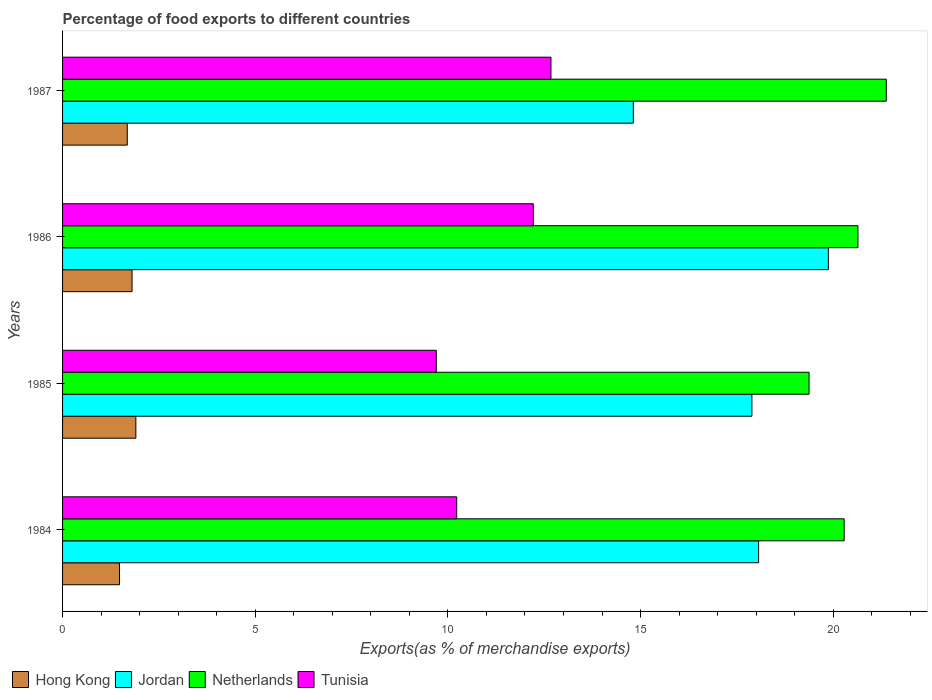Are the number of bars per tick equal to the number of legend labels?
Offer a very short reply. Yes. Are the number of bars on each tick of the Y-axis equal?
Offer a very short reply. Yes. What is the label of the 4th group of bars from the top?
Ensure brevity in your answer.  1984. In how many cases, is the number of bars for a given year not equal to the number of legend labels?
Keep it short and to the point. 0. What is the percentage of exports to different countries in Tunisia in 1985?
Your answer should be very brief. 9.7. Across all years, what is the maximum percentage of exports to different countries in Tunisia?
Make the answer very short. 12.67. Across all years, what is the minimum percentage of exports to different countries in Tunisia?
Keep it short and to the point. 9.7. What is the total percentage of exports to different countries in Netherlands in the graph?
Provide a succinct answer. 81.67. What is the difference between the percentage of exports to different countries in Tunisia in 1985 and that in 1986?
Offer a very short reply. -2.52. What is the difference between the percentage of exports to different countries in Netherlands in 1987 and the percentage of exports to different countries in Jordan in 1985?
Give a very brief answer. 3.49. What is the average percentage of exports to different countries in Netherlands per year?
Provide a short and direct response. 20.42. In the year 1984, what is the difference between the percentage of exports to different countries in Tunisia and percentage of exports to different countries in Jordan?
Your answer should be very brief. -7.83. What is the ratio of the percentage of exports to different countries in Netherlands in 1985 to that in 1987?
Offer a terse response. 0.91. Is the difference between the percentage of exports to different countries in Tunisia in 1986 and 1987 greater than the difference between the percentage of exports to different countries in Jordan in 1986 and 1987?
Your answer should be compact. No. What is the difference between the highest and the second highest percentage of exports to different countries in Jordan?
Give a very brief answer. 1.81. What is the difference between the highest and the lowest percentage of exports to different countries in Netherlands?
Provide a succinct answer. 2. In how many years, is the percentage of exports to different countries in Jordan greater than the average percentage of exports to different countries in Jordan taken over all years?
Ensure brevity in your answer.  3. Is the sum of the percentage of exports to different countries in Jordan in 1984 and 1985 greater than the maximum percentage of exports to different countries in Hong Kong across all years?
Give a very brief answer. Yes. What does the 4th bar from the top in 1986 represents?
Provide a succinct answer. Hong Kong. What does the 4th bar from the bottom in 1986 represents?
Your answer should be compact. Tunisia. How many bars are there?
Give a very brief answer. 16. Are all the bars in the graph horizontal?
Your response must be concise. Yes. How many years are there in the graph?
Your answer should be compact. 4. What is the difference between two consecutive major ticks on the X-axis?
Ensure brevity in your answer.  5. Does the graph contain any zero values?
Your response must be concise. No. Does the graph contain grids?
Offer a very short reply. No. What is the title of the graph?
Ensure brevity in your answer.  Percentage of food exports to different countries. What is the label or title of the X-axis?
Ensure brevity in your answer.  Exports(as % of merchandise exports). What is the label or title of the Y-axis?
Your answer should be compact. Years. What is the Exports(as % of merchandise exports) in Hong Kong in 1984?
Your answer should be compact. 1.48. What is the Exports(as % of merchandise exports) in Jordan in 1984?
Offer a terse response. 18.06. What is the Exports(as % of merchandise exports) in Netherlands in 1984?
Your response must be concise. 20.28. What is the Exports(as % of merchandise exports) of Tunisia in 1984?
Provide a short and direct response. 10.23. What is the Exports(as % of merchandise exports) of Hong Kong in 1985?
Ensure brevity in your answer.  1.9. What is the Exports(as % of merchandise exports) in Jordan in 1985?
Offer a very short reply. 17.89. What is the Exports(as % of merchandise exports) of Netherlands in 1985?
Provide a succinct answer. 19.37. What is the Exports(as % of merchandise exports) in Tunisia in 1985?
Your answer should be very brief. 9.7. What is the Exports(as % of merchandise exports) of Hong Kong in 1986?
Make the answer very short. 1.8. What is the Exports(as % of merchandise exports) in Jordan in 1986?
Your answer should be compact. 19.87. What is the Exports(as % of merchandise exports) in Netherlands in 1986?
Your response must be concise. 20.64. What is the Exports(as % of merchandise exports) in Tunisia in 1986?
Give a very brief answer. 12.22. What is the Exports(as % of merchandise exports) of Hong Kong in 1987?
Offer a very short reply. 1.68. What is the Exports(as % of merchandise exports) in Jordan in 1987?
Ensure brevity in your answer.  14.81. What is the Exports(as % of merchandise exports) in Netherlands in 1987?
Offer a terse response. 21.38. What is the Exports(as % of merchandise exports) in Tunisia in 1987?
Offer a terse response. 12.67. Across all years, what is the maximum Exports(as % of merchandise exports) of Hong Kong?
Offer a very short reply. 1.9. Across all years, what is the maximum Exports(as % of merchandise exports) of Jordan?
Your answer should be compact. 19.87. Across all years, what is the maximum Exports(as % of merchandise exports) of Netherlands?
Offer a very short reply. 21.38. Across all years, what is the maximum Exports(as % of merchandise exports) of Tunisia?
Offer a terse response. 12.67. Across all years, what is the minimum Exports(as % of merchandise exports) in Hong Kong?
Offer a terse response. 1.48. Across all years, what is the minimum Exports(as % of merchandise exports) in Jordan?
Your response must be concise. 14.81. Across all years, what is the minimum Exports(as % of merchandise exports) in Netherlands?
Provide a succinct answer. 19.37. Across all years, what is the minimum Exports(as % of merchandise exports) of Tunisia?
Offer a terse response. 9.7. What is the total Exports(as % of merchandise exports) in Hong Kong in the graph?
Offer a very short reply. 6.86. What is the total Exports(as % of merchandise exports) of Jordan in the graph?
Provide a short and direct response. 70.64. What is the total Exports(as % of merchandise exports) in Netherlands in the graph?
Offer a terse response. 81.67. What is the total Exports(as % of merchandise exports) in Tunisia in the graph?
Keep it short and to the point. 44.82. What is the difference between the Exports(as % of merchandise exports) in Hong Kong in 1984 and that in 1985?
Provide a short and direct response. -0.42. What is the difference between the Exports(as % of merchandise exports) in Jordan in 1984 and that in 1985?
Your response must be concise. 0.17. What is the difference between the Exports(as % of merchandise exports) in Netherlands in 1984 and that in 1985?
Make the answer very short. 0.91. What is the difference between the Exports(as % of merchandise exports) of Tunisia in 1984 and that in 1985?
Give a very brief answer. 0.53. What is the difference between the Exports(as % of merchandise exports) in Hong Kong in 1984 and that in 1986?
Your answer should be compact. -0.33. What is the difference between the Exports(as % of merchandise exports) of Jordan in 1984 and that in 1986?
Ensure brevity in your answer.  -1.81. What is the difference between the Exports(as % of merchandise exports) in Netherlands in 1984 and that in 1986?
Offer a very short reply. -0.36. What is the difference between the Exports(as % of merchandise exports) in Tunisia in 1984 and that in 1986?
Make the answer very short. -1.99. What is the difference between the Exports(as % of merchandise exports) in Hong Kong in 1984 and that in 1987?
Provide a short and direct response. -0.2. What is the difference between the Exports(as % of merchandise exports) of Jordan in 1984 and that in 1987?
Ensure brevity in your answer.  3.25. What is the difference between the Exports(as % of merchandise exports) in Netherlands in 1984 and that in 1987?
Give a very brief answer. -1.09. What is the difference between the Exports(as % of merchandise exports) in Tunisia in 1984 and that in 1987?
Offer a very short reply. -2.45. What is the difference between the Exports(as % of merchandise exports) of Hong Kong in 1985 and that in 1986?
Your answer should be very brief. 0.1. What is the difference between the Exports(as % of merchandise exports) of Jordan in 1985 and that in 1986?
Your answer should be very brief. -1.98. What is the difference between the Exports(as % of merchandise exports) of Netherlands in 1985 and that in 1986?
Give a very brief answer. -1.27. What is the difference between the Exports(as % of merchandise exports) in Tunisia in 1985 and that in 1986?
Keep it short and to the point. -2.52. What is the difference between the Exports(as % of merchandise exports) of Hong Kong in 1985 and that in 1987?
Provide a short and direct response. 0.22. What is the difference between the Exports(as % of merchandise exports) of Jordan in 1985 and that in 1987?
Give a very brief answer. 3.08. What is the difference between the Exports(as % of merchandise exports) of Netherlands in 1985 and that in 1987?
Provide a short and direct response. -2. What is the difference between the Exports(as % of merchandise exports) of Tunisia in 1985 and that in 1987?
Give a very brief answer. -2.98. What is the difference between the Exports(as % of merchandise exports) of Hong Kong in 1986 and that in 1987?
Provide a succinct answer. 0.12. What is the difference between the Exports(as % of merchandise exports) in Jordan in 1986 and that in 1987?
Your answer should be very brief. 5.06. What is the difference between the Exports(as % of merchandise exports) in Netherlands in 1986 and that in 1987?
Your answer should be compact. -0.74. What is the difference between the Exports(as % of merchandise exports) in Tunisia in 1986 and that in 1987?
Keep it short and to the point. -0.46. What is the difference between the Exports(as % of merchandise exports) of Hong Kong in 1984 and the Exports(as % of merchandise exports) of Jordan in 1985?
Ensure brevity in your answer.  -16.41. What is the difference between the Exports(as % of merchandise exports) in Hong Kong in 1984 and the Exports(as % of merchandise exports) in Netherlands in 1985?
Ensure brevity in your answer.  -17.89. What is the difference between the Exports(as % of merchandise exports) of Hong Kong in 1984 and the Exports(as % of merchandise exports) of Tunisia in 1985?
Your answer should be very brief. -8.22. What is the difference between the Exports(as % of merchandise exports) in Jordan in 1984 and the Exports(as % of merchandise exports) in Netherlands in 1985?
Make the answer very short. -1.31. What is the difference between the Exports(as % of merchandise exports) of Jordan in 1984 and the Exports(as % of merchandise exports) of Tunisia in 1985?
Make the answer very short. 8.36. What is the difference between the Exports(as % of merchandise exports) in Netherlands in 1984 and the Exports(as % of merchandise exports) in Tunisia in 1985?
Your answer should be compact. 10.58. What is the difference between the Exports(as % of merchandise exports) in Hong Kong in 1984 and the Exports(as % of merchandise exports) in Jordan in 1986?
Provide a succinct answer. -18.4. What is the difference between the Exports(as % of merchandise exports) in Hong Kong in 1984 and the Exports(as % of merchandise exports) in Netherlands in 1986?
Your answer should be compact. -19.16. What is the difference between the Exports(as % of merchandise exports) in Hong Kong in 1984 and the Exports(as % of merchandise exports) in Tunisia in 1986?
Offer a very short reply. -10.74. What is the difference between the Exports(as % of merchandise exports) in Jordan in 1984 and the Exports(as % of merchandise exports) in Netherlands in 1986?
Offer a very short reply. -2.58. What is the difference between the Exports(as % of merchandise exports) of Jordan in 1984 and the Exports(as % of merchandise exports) of Tunisia in 1986?
Give a very brief answer. 5.85. What is the difference between the Exports(as % of merchandise exports) of Netherlands in 1984 and the Exports(as % of merchandise exports) of Tunisia in 1986?
Your answer should be compact. 8.07. What is the difference between the Exports(as % of merchandise exports) of Hong Kong in 1984 and the Exports(as % of merchandise exports) of Jordan in 1987?
Offer a terse response. -13.33. What is the difference between the Exports(as % of merchandise exports) in Hong Kong in 1984 and the Exports(as % of merchandise exports) in Netherlands in 1987?
Offer a terse response. -19.9. What is the difference between the Exports(as % of merchandise exports) in Hong Kong in 1984 and the Exports(as % of merchandise exports) in Tunisia in 1987?
Provide a short and direct response. -11.2. What is the difference between the Exports(as % of merchandise exports) in Jordan in 1984 and the Exports(as % of merchandise exports) in Netherlands in 1987?
Give a very brief answer. -3.31. What is the difference between the Exports(as % of merchandise exports) in Jordan in 1984 and the Exports(as % of merchandise exports) in Tunisia in 1987?
Make the answer very short. 5.39. What is the difference between the Exports(as % of merchandise exports) of Netherlands in 1984 and the Exports(as % of merchandise exports) of Tunisia in 1987?
Your answer should be very brief. 7.61. What is the difference between the Exports(as % of merchandise exports) of Hong Kong in 1985 and the Exports(as % of merchandise exports) of Jordan in 1986?
Keep it short and to the point. -17.97. What is the difference between the Exports(as % of merchandise exports) of Hong Kong in 1985 and the Exports(as % of merchandise exports) of Netherlands in 1986?
Make the answer very short. -18.74. What is the difference between the Exports(as % of merchandise exports) of Hong Kong in 1985 and the Exports(as % of merchandise exports) of Tunisia in 1986?
Your answer should be compact. -10.31. What is the difference between the Exports(as % of merchandise exports) in Jordan in 1985 and the Exports(as % of merchandise exports) in Netherlands in 1986?
Your answer should be very brief. -2.75. What is the difference between the Exports(as % of merchandise exports) in Jordan in 1985 and the Exports(as % of merchandise exports) in Tunisia in 1986?
Offer a terse response. 5.67. What is the difference between the Exports(as % of merchandise exports) of Netherlands in 1985 and the Exports(as % of merchandise exports) of Tunisia in 1986?
Make the answer very short. 7.16. What is the difference between the Exports(as % of merchandise exports) in Hong Kong in 1985 and the Exports(as % of merchandise exports) in Jordan in 1987?
Offer a terse response. -12.91. What is the difference between the Exports(as % of merchandise exports) of Hong Kong in 1985 and the Exports(as % of merchandise exports) of Netherlands in 1987?
Provide a succinct answer. -19.47. What is the difference between the Exports(as % of merchandise exports) of Hong Kong in 1985 and the Exports(as % of merchandise exports) of Tunisia in 1987?
Offer a terse response. -10.77. What is the difference between the Exports(as % of merchandise exports) of Jordan in 1985 and the Exports(as % of merchandise exports) of Netherlands in 1987?
Your answer should be compact. -3.49. What is the difference between the Exports(as % of merchandise exports) in Jordan in 1985 and the Exports(as % of merchandise exports) in Tunisia in 1987?
Offer a very short reply. 5.21. What is the difference between the Exports(as % of merchandise exports) of Netherlands in 1985 and the Exports(as % of merchandise exports) of Tunisia in 1987?
Offer a very short reply. 6.7. What is the difference between the Exports(as % of merchandise exports) of Hong Kong in 1986 and the Exports(as % of merchandise exports) of Jordan in 1987?
Make the answer very short. -13.01. What is the difference between the Exports(as % of merchandise exports) of Hong Kong in 1986 and the Exports(as % of merchandise exports) of Netherlands in 1987?
Give a very brief answer. -19.57. What is the difference between the Exports(as % of merchandise exports) of Hong Kong in 1986 and the Exports(as % of merchandise exports) of Tunisia in 1987?
Give a very brief answer. -10.87. What is the difference between the Exports(as % of merchandise exports) in Jordan in 1986 and the Exports(as % of merchandise exports) in Netherlands in 1987?
Provide a short and direct response. -1.5. What is the difference between the Exports(as % of merchandise exports) in Jordan in 1986 and the Exports(as % of merchandise exports) in Tunisia in 1987?
Offer a terse response. 7.2. What is the difference between the Exports(as % of merchandise exports) in Netherlands in 1986 and the Exports(as % of merchandise exports) in Tunisia in 1987?
Offer a terse response. 7.97. What is the average Exports(as % of merchandise exports) in Hong Kong per year?
Ensure brevity in your answer.  1.72. What is the average Exports(as % of merchandise exports) of Jordan per year?
Your answer should be very brief. 17.66. What is the average Exports(as % of merchandise exports) in Netherlands per year?
Give a very brief answer. 20.42. What is the average Exports(as % of merchandise exports) in Tunisia per year?
Make the answer very short. 11.2. In the year 1984, what is the difference between the Exports(as % of merchandise exports) in Hong Kong and Exports(as % of merchandise exports) in Jordan?
Provide a succinct answer. -16.58. In the year 1984, what is the difference between the Exports(as % of merchandise exports) of Hong Kong and Exports(as % of merchandise exports) of Netherlands?
Your answer should be compact. -18.8. In the year 1984, what is the difference between the Exports(as % of merchandise exports) in Hong Kong and Exports(as % of merchandise exports) in Tunisia?
Keep it short and to the point. -8.75. In the year 1984, what is the difference between the Exports(as % of merchandise exports) of Jordan and Exports(as % of merchandise exports) of Netherlands?
Provide a short and direct response. -2.22. In the year 1984, what is the difference between the Exports(as % of merchandise exports) of Jordan and Exports(as % of merchandise exports) of Tunisia?
Your answer should be compact. 7.83. In the year 1984, what is the difference between the Exports(as % of merchandise exports) in Netherlands and Exports(as % of merchandise exports) in Tunisia?
Keep it short and to the point. 10.05. In the year 1985, what is the difference between the Exports(as % of merchandise exports) of Hong Kong and Exports(as % of merchandise exports) of Jordan?
Offer a very short reply. -15.99. In the year 1985, what is the difference between the Exports(as % of merchandise exports) in Hong Kong and Exports(as % of merchandise exports) in Netherlands?
Keep it short and to the point. -17.47. In the year 1985, what is the difference between the Exports(as % of merchandise exports) of Hong Kong and Exports(as % of merchandise exports) of Tunisia?
Provide a succinct answer. -7.8. In the year 1985, what is the difference between the Exports(as % of merchandise exports) in Jordan and Exports(as % of merchandise exports) in Netherlands?
Provide a short and direct response. -1.48. In the year 1985, what is the difference between the Exports(as % of merchandise exports) of Jordan and Exports(as % of merchandise exports) of Tunisia?
Your answer should be very brief. 8.19. In the year 1985, what is the difference between the Exports(as % of merchandise exports) of Netherlands and Exports(as % of merchandise exports) of Tunisia?
Offer a terse response. 9.67. In the year 1986, what is the difference between the Exports(as % of merchandise exports) in Hong Kong and Exports(as % of merchandise exports) in Jordan?
Offer a very short reply. -18.07. In the year 1986, what is the difference between the Exports(as % of merchandise exports) in Hong Kong and Exports(as % of merchandise exports) in Netherlands?
Provide a succinct answer. -18.84. In the year 1986, what is the difference between the Exports(as % of merchandise exports) of Hong Kong and Exports(as % of merchandise exports) of Tunisia?
Ensure brevity in your answer.  -10.41. In the year 1986, what is the difference between the Exports(as % of merchandise exports) in Jordan and Exports(as % of merchandise exports) in Netherlands?
Provide a succinct answer. -0.77. In the year 1986, what is the difference between the Exports(as % of merchandise exports) of Jordan and Exports(as % of merchandise exports) of Tunisia?
Your answer should be compact. 7.66. In the year 1986, what is the difference between the Exports(as % of merchandise exports) of Netherlands and Exports(as % of merchandise exports) of Tunisia?
Keep it short and to the point. 8.42. In the year 1987, what is the difference between the Exports(as % of merchandise exports) of Hong Kong and Exports(as % of merchandise exports) of Jordan?
Ensure brevity in your answer.  -13.13. In the year 1987, what is the difference between the Exports(as % of merchandise exports) in Hong Kong and Exports(as % of merchandise exports) in Netherlands?
Provide a succinct answer. -19.7. In the year 1987, what is the difference between the Exports(as % of merchandise exports) in Hong Kong and Exports(as % of merchandise exports) in Tunisia?
Your answer should be compact. -10.99. In the year 1987, what is the difference between the Exports(as % of merchandise exports) of Jordan and Exports(as % of merchandise exports) of Netherlands?
Provide a short and direct response. -6.56. In the year 1987, what is the difference between the Exports(as % of merchandise exports) of Jordan and Exports(as % of merchandise exports) of Tunisia?
Make the answer very short. 2.14. In the year 1987, what is the difference between the Exports(as % of merchandise exports) in Netherlands and Exports(as % of merchandise exports) in Tunisia?
Your answer should be compact. 8.7. What is the ratio of the Exports(as % of merchandise exports) of Hong Kong in 1984 to that in 1985?
Your answer should be very brief. 0.78. What is the ratio of the Exports(as % of merchandise exports) in Jordan in 1984 to that in 1985?
Provide a succinct answer. 1.01. What is the ratio of the Exports(as % of merchandise exports) of Netherlands in 1984 to that in 1985?
Provide a short and direct response. 1.05. What is the ratio of the Exports(as % of merchandise exports) in Tunisia in 1984 to that in 1985?
Provide a succinct answer. 1.05. What is the ratio of the Exports(as % of merchandise exports) in Hong Kong in 1984 to that in 1986?
Offer a terse response. 0.82. What is the ratio of the Exports(as % of merchandise exports) in Jordan in 1984 to that in 1986?
Your response must be concise. 0.91. What is the ratio of the Exports(as % of merchandise exports) of Netherlands in 1984 to that in 1986?
Ensure brevity in your answer.  0.98. What is the ratio of the Exports(as % of merchandise exports) of Tunisia in 1984 to that in 1986?
Your response must be concise. 0.84. What is the ratio of the Exports(as % of merchandise exports) in Hong Kong in 1984 to that in 1987?
Provide a short and direct response. 0.88. What is the ratio of the Exports(as % of merchandise exports) in Jordan in 1984 to that in 1987?
Provide a succinct answer. 1.22. What is the ratio of the Exports(as % of merchandise exports) in Netherlands in 1984 to that in 1987?
Provide a succinct answer. 0.95. What is the ratio of the Exports(as % of merchandise exports) of Tunisia in 1984 to that in 1987?
Keep it short and to the point. 0.81. What is the ratio of the Exports(as % of merchandise exports) of Hong Kong in 1985 to that in 1986?
Your answer should be very brief. 1.05. What is the ratio of the Exports(as % of merchandise exports) of Jordan in 1985 to that in 1986?
Your answer should be compact. 0.9. What is the ratio of the Exports(as % of merchandise exports) in Netherlands in 1985 to that in 1986?
Your answer should be compact. 0.94. What is the ratio of the Exports(as % of merchandise exports) in Tunisia in 1985 to that in 1986?
Provide a succinct answer. 0.79. What is the ratio of the Exports(as % of merchandise exports) in Hong Kong in 1985 to that in 1987?
Provide a short and direct response. 1.13. What is the ratio of the Exports(as % of merchandise exports) in Jordan in 1985 to that in 1987?
Your response must be concise. 1.21. What is the ratio of the Exports(as % of merchandise exports) in Netherlands in 1985 to that in 1987?
Make the answer very short. 0.91. What is the ratio of the Exports(as % of merchandise exports) of Tunisia in 1985 to that in 1987?
Your response must be concise. 0.77. What is the ratio of the Exports(as % of merchandise exports) in Hong Kong in 1986 to that in 1987?
Offer a very short reply. 1.07. What is the ratio of the Exports(as % of merchandise exports) of Jordan in 1986 to that in 1987?
Your answer should be very brief. 1.34. What is the ratio of the Exports(as % of merchandise exports) in Netherlands in 1986 to that in 1987?
Keep it short and to the point. 0.97. What is the ratio of the Exports(as % of merchandise exports) of Tunisia in 1986 to that in 1987?
Make the answer very short. 0.96. What is the difference between the highest and the second highest Exports(as % of merchandise exports) of Hong Kong?
Your answer should be compact. 0.1. What is the difference between the highest and the second highest Exports(as % of merchandise exports) of Jordan?
Keep it short and to the point. 1.81. What is the difference between the highest and the second highest Exports(as % of merchandise exports) in Netherlands?
Make the answer very short. 0.74. What is the difference between the highest and the second highest Exports(as % of merchandise exports) in Tunisia?
Give a very brief answer. 0.46. What is the difference between the highest and the lowest Exports(as % of merchandise exports) in Hong Kong?
Ensure brevity in your answer.  0.42. What is the difference between the highest and the lowest Exports(as % of merchandise exports) of Jordan?
Make the answer very short. 5.06. What is the difference between the highest and the lowest Exports(as % of merchandise exports) in Netherlands?
Keep it short and to the point. 2. What is the difference between the highest and the lowest Exports(as % of merchandise exports) of Tunisia?
Offer a terse response. 2.98. 